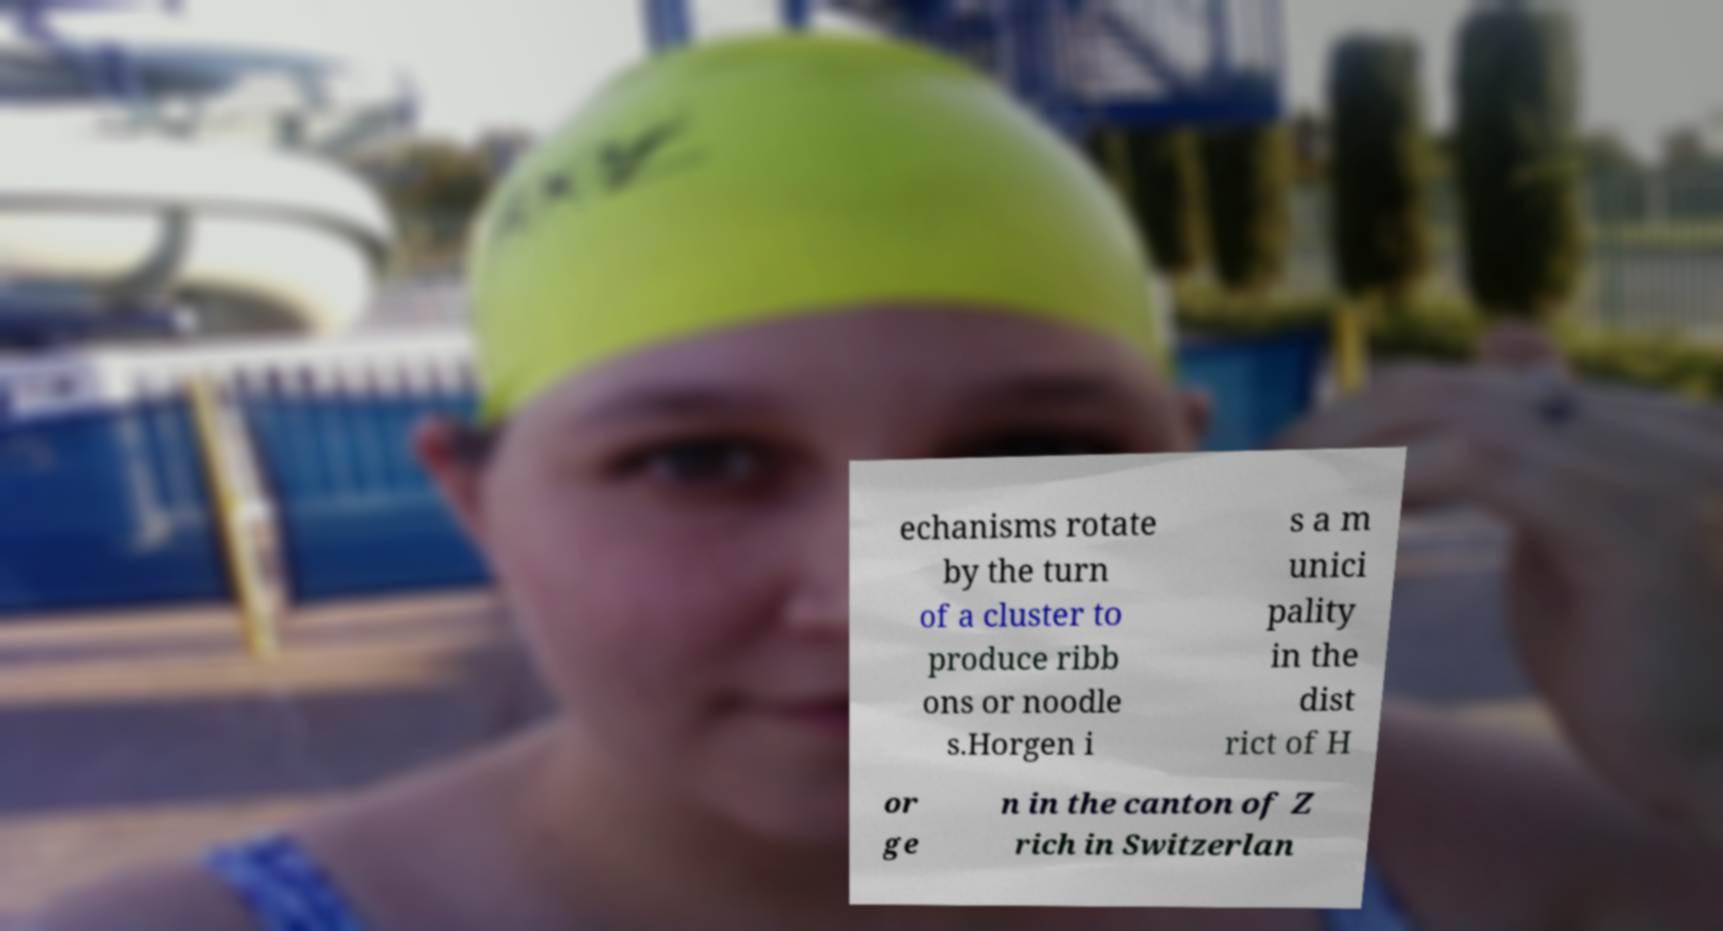Can you read and provide the text displayed in the image?This photo seems to have some interesting text. Can you extract and type it out for me? echanisms rotate by the turn of a cluster to produce ribb ons or noodle s.Horgen i s a m unici pality in the dist rict of H or ge n in the canton of Z rich in Switzerlan 